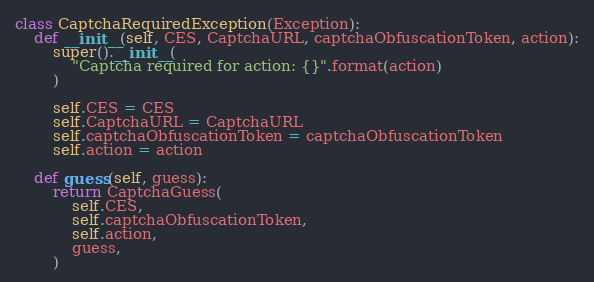Convert code to text. <code><loc_0><loc_0><loc_500><loc_500><_Python_>class CaptchaRequiredException(Exception):
    def __init__(self, CES, CaptchaURL, captchaObfuscationToken, action):
        super().__init__(
            "Captcha required for action: {}".format(action)
        )

        self.CES = CES
        self.CaptchaURL = CaptchaURL
        self.captchaObfuscationToken = captchaObfuscationToken
        self.action = action

    def guess(self, guess):
        return CaptchaGuess(
            self.CES,
            self.captchaObfuscationToken,
            self.action,
            guess,
        )</code> 